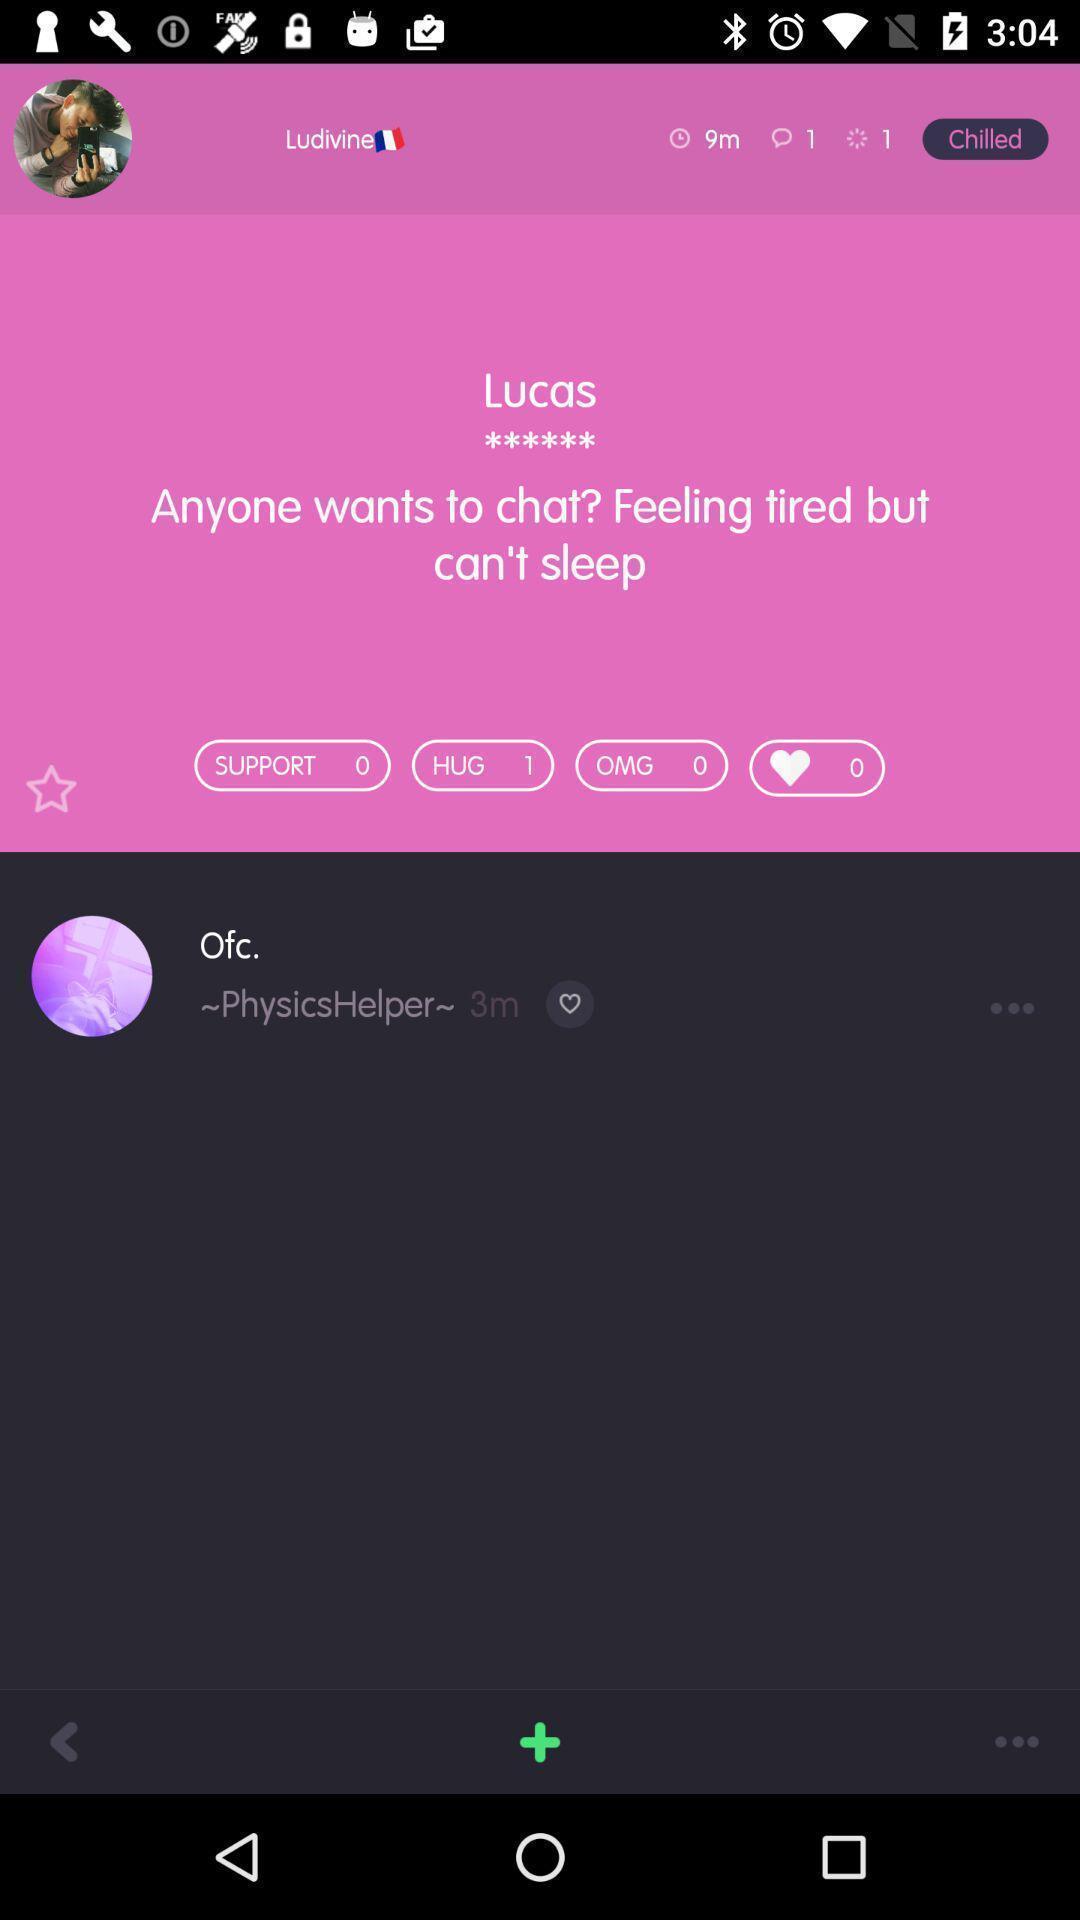Explain the elements present in this screenshot. Page displays a profile in chatting application. 